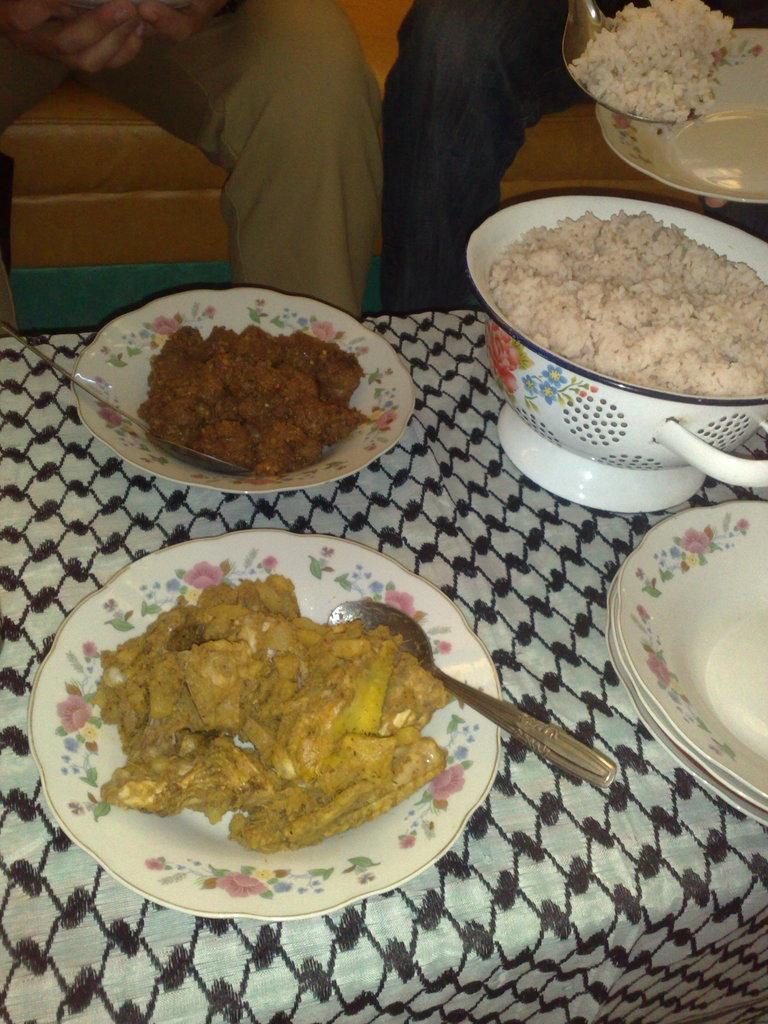What is located in the foreground of the picture? There is a table in the foreground of the picture. What items can be seen on the table? There are plates, bowls, rice, spoons, and dishes on the table. What are the people in the image doing? The two people are sitting on a couch at the top of the image. What type of nerve can be seen connecting the two people on the couch? There is no nerve visible in the image; it features a table with various items and two people sitting on a couch. 